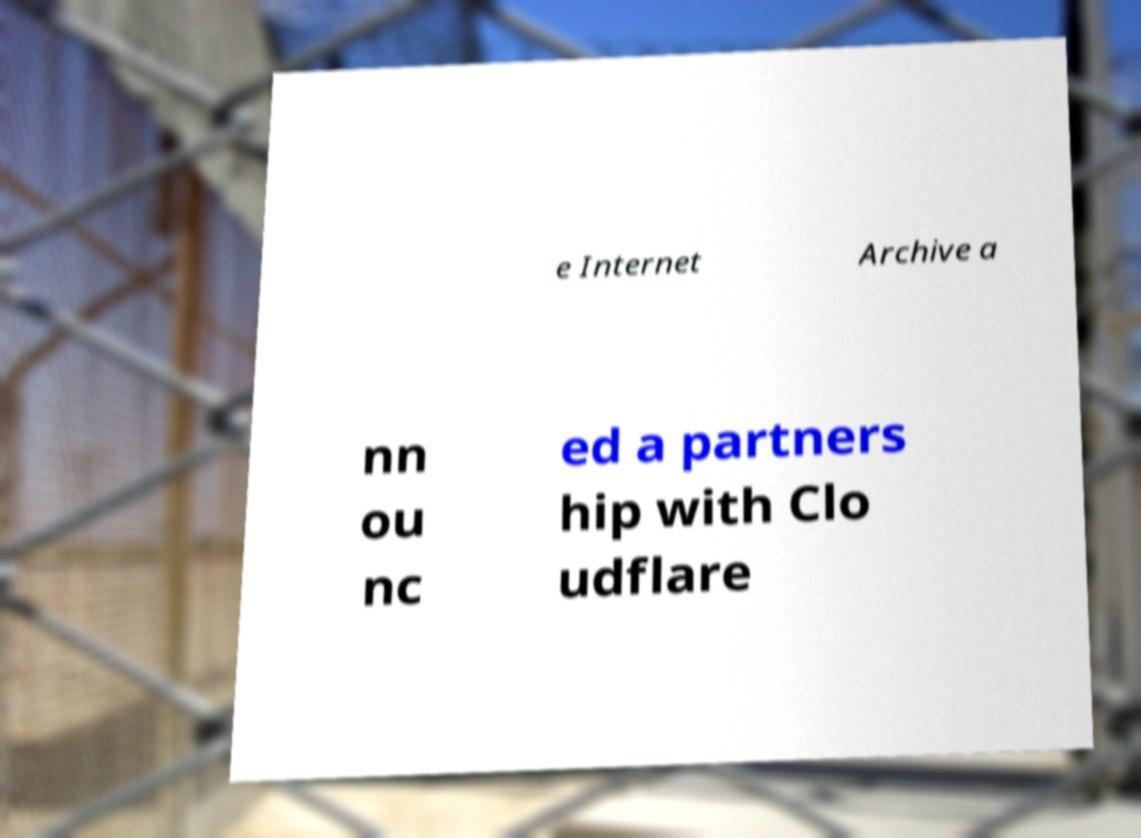For documentation purposes, I need the text within this image transcribed. Could you provide that? e Internet Archive a nn ou nc ed a partners hip with Clo udflare 